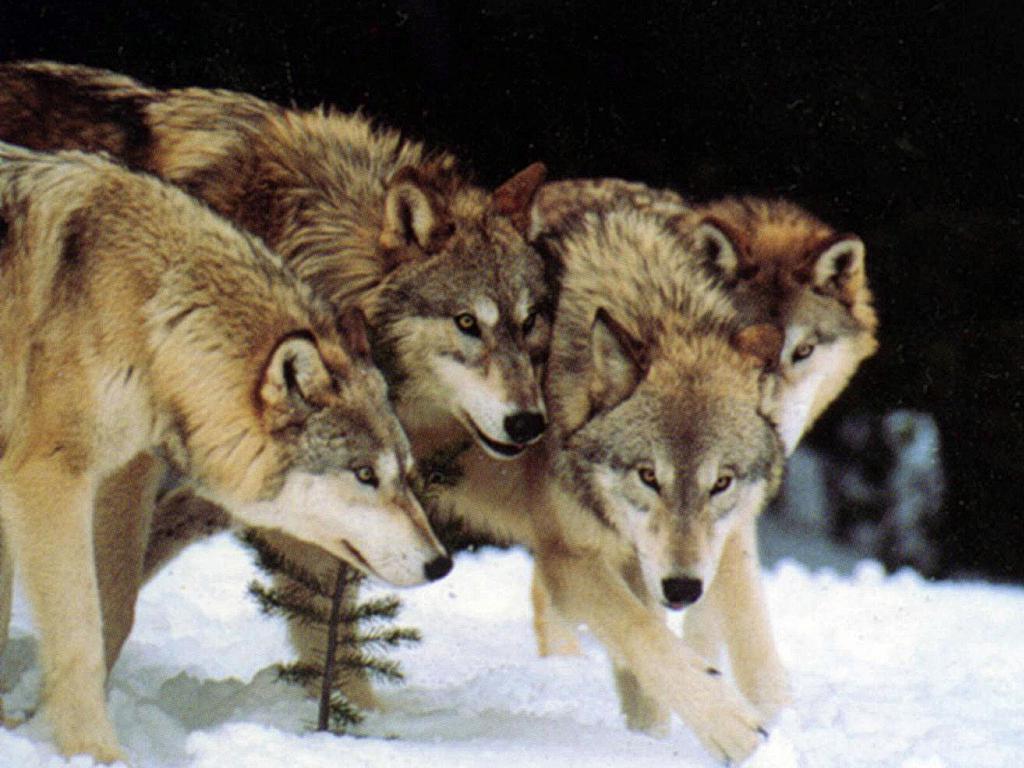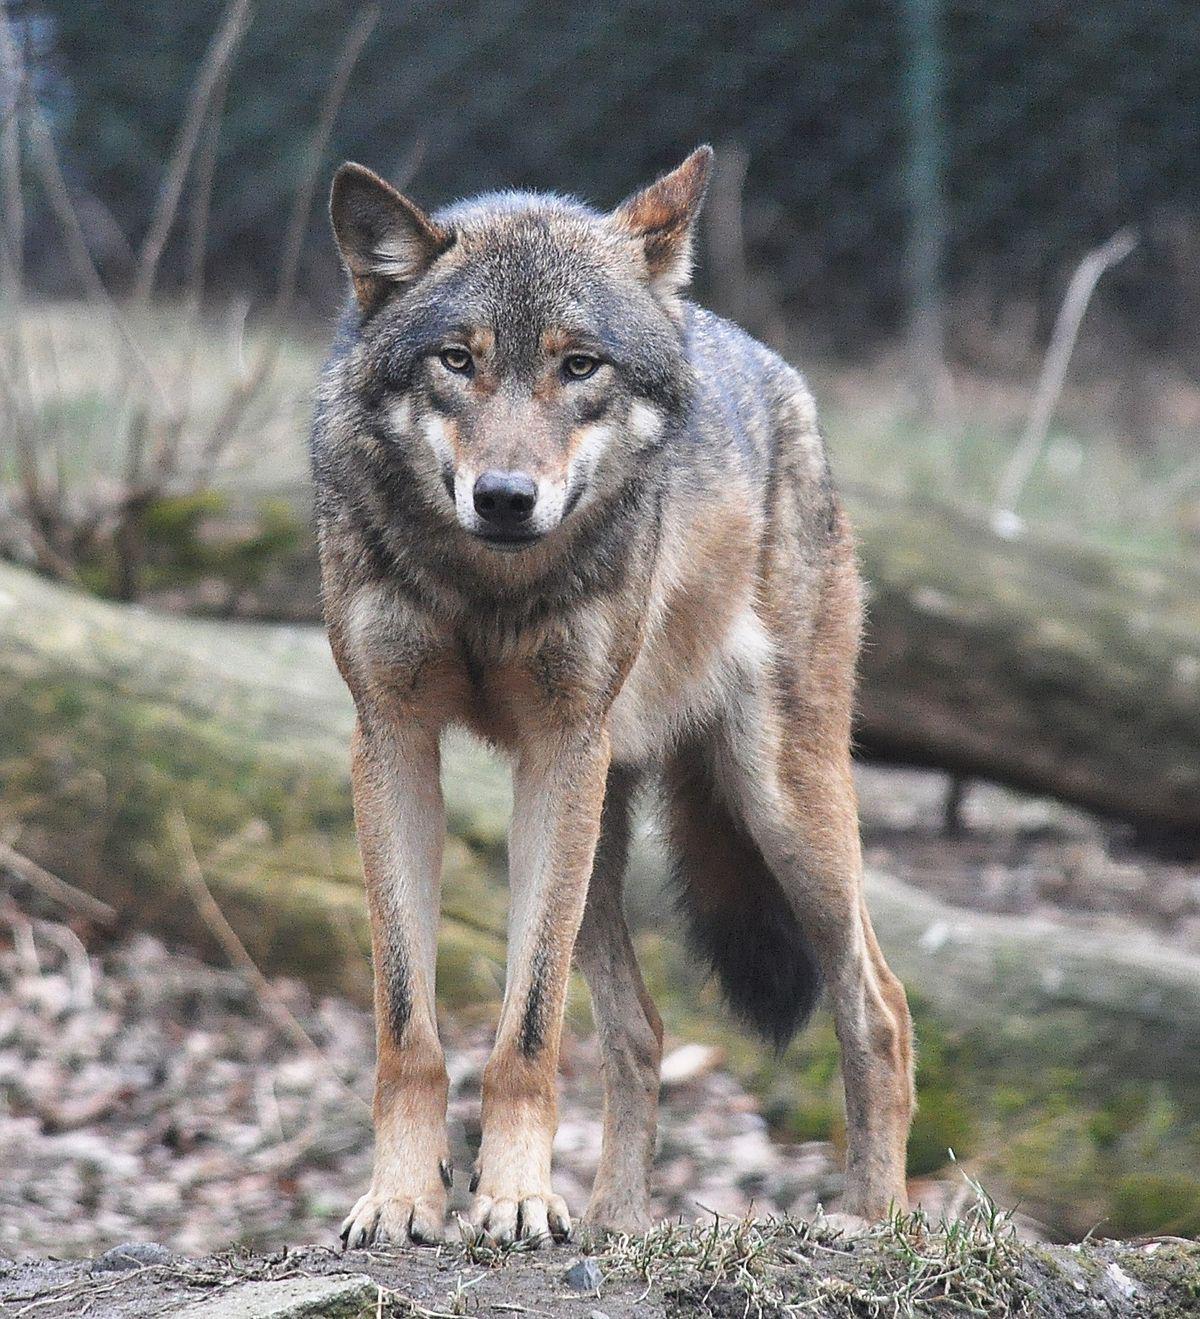The first image is the image on the left, the second image is the image on the right. For the images shown, is this caption "One image includes at least three standing similar-looking wolves in a snowy scene." true? Answer yes or no. Yes. The first image is the image on the left, the second image is the image on the right. Given the left and right images, does the statement "The wolf in the right image is facing towards the right." hold true? Answer yes or no. No. 